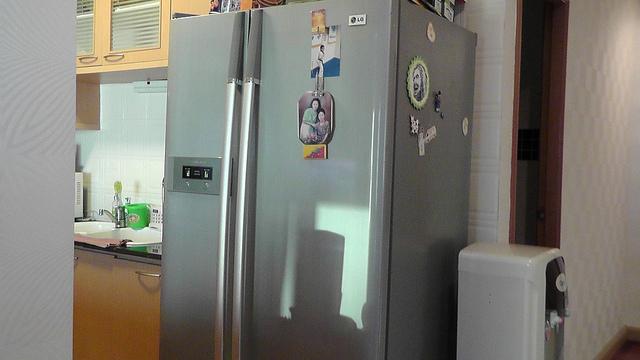Is the refrigerator door closed?
Keep it brief. Yes. What is this container?
Answer briefly. Refrigerator. How many magnets are on the fridge?
Quick response, please. 10. Does the fridge look new?
Concise answer only. Yes. What color is the fridge?
Give a very brief answer. Silver. Is there a microwave?
Concise answer only. No. Is this a door on a train?
Short answer required. No. What color is the refrigerator?
Quick response, please. Silver. What is the silver thing?
Keep it brief. Refrigerator. What appliance is this?
Write a very short answer. Refrigerator. What's beside the appliance?
Short answer required. Heater. Is there a roll of paper towels in the picture?
Be succinct. No. 